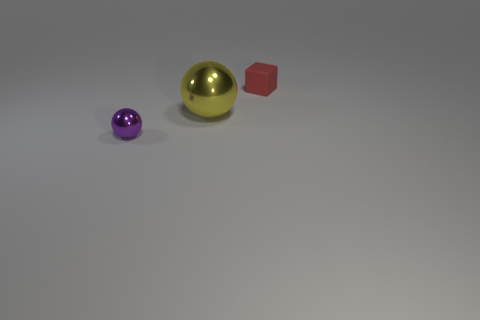Add 3 tiny brown blocks. How many objects exist? 6 Subtract all spheres. How many objects are left? 1 Subtract all tiny green shiny cylinders. Subtract all metallic balls. How many objects are left? 1 Add 1 rubber things. How many rubber things are left? 2 Add 2 big brown metal cylinders. How many big brown metal cylinders exist? 2 Subtract 0 blue cubes. How many objects are left? 3 